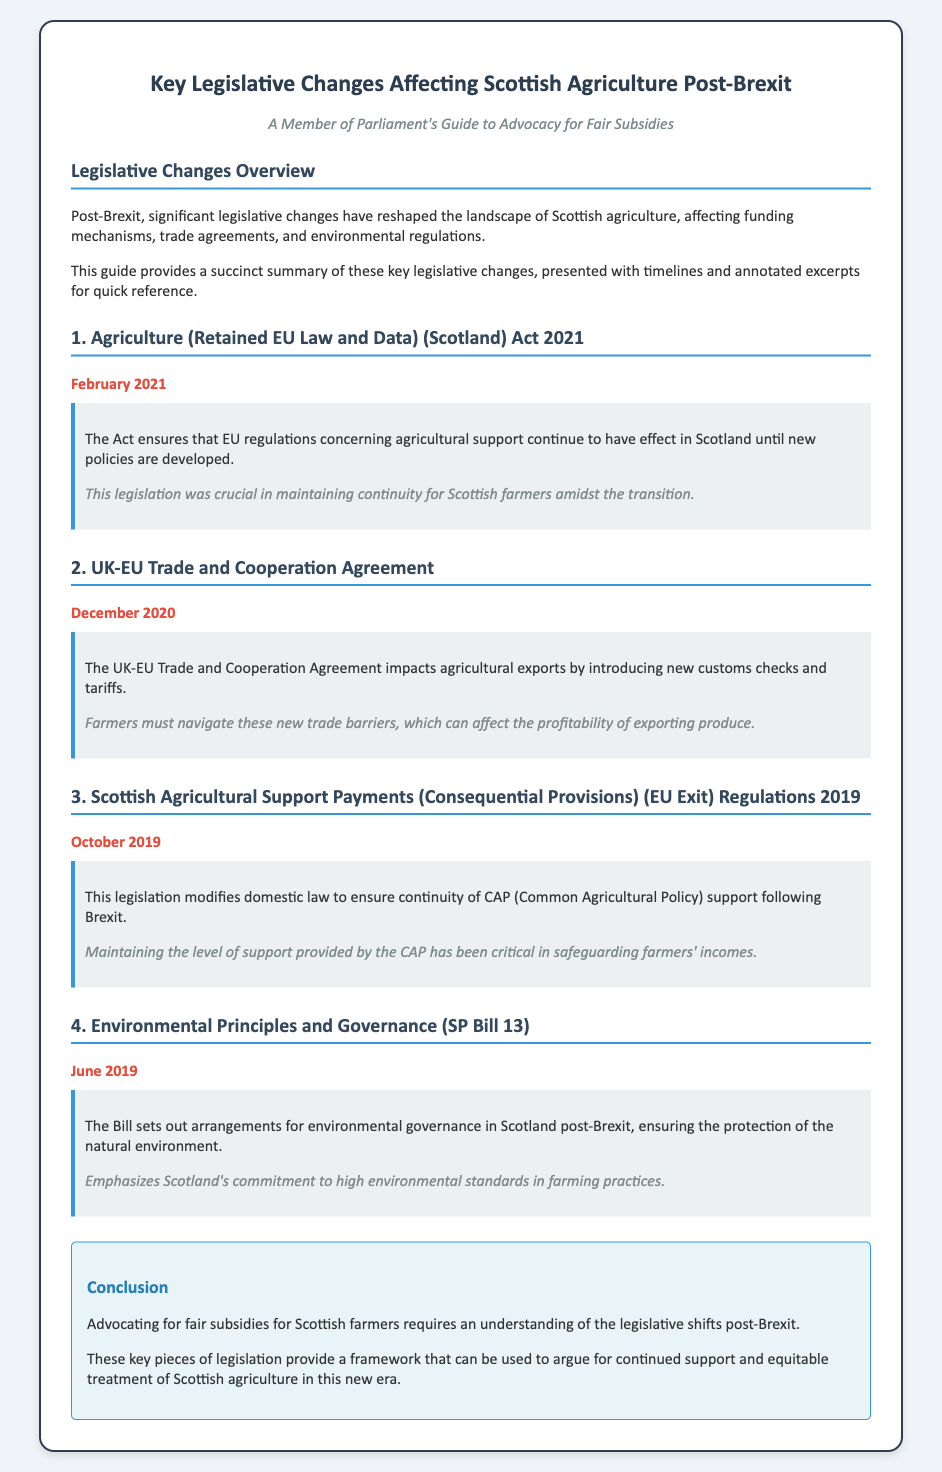What is the title of the document? The title of the document summarizes its content regarding legislative changes affecting agriculture in Scotland post-Brexit.
Answer: Key Legislative Changes Affecting Scottish Agriculture Post-Brexit When was the Agriculture (Retained EU Law and Data) (Scotland) Act passed? The document specifies the timeline of this act, providing a specific month and year.
Answer: February 2021 What does the UK-EU Trade and Cooperation Agreement introduce? The excerpt mentions specific changes brought by this agreement that affect agricultural exports.
Answer: New customs checks and tariffs What was the purpose of the Scottish Agricultural Support Payments (Consequential Provisions) (EU Exit) Regulations 2019? The excerpt explains the legislative modification relating to farm support following Brexit.
Answer: Ensure continuity of CAP support What is emphasized by the Environmental Principles and Governance (SP Bill 13)? The document highlights the significance of environmental standards in the context of this bill.
Answer: Commitment to high environmental standards What do these legislative changes provide a framework for? The conclusion suggests a broader aim of these legislative modifications for Scottish agriculture.
Answer: Continued support and equitable treatment of Scottish agriculture 